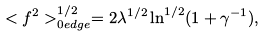Convert formula to latex. <formula><loc_0><loc_0><loc_500><loc_500>< f ^ { 2 } > _ { 0 e d g e } ^ { 1 / 2 } = 2 \lambda ^ { 1 / 2 } \ln ^ { 1 / 2 } ( 1 + \gamma ^ { - 1 } ) ,</formula> 